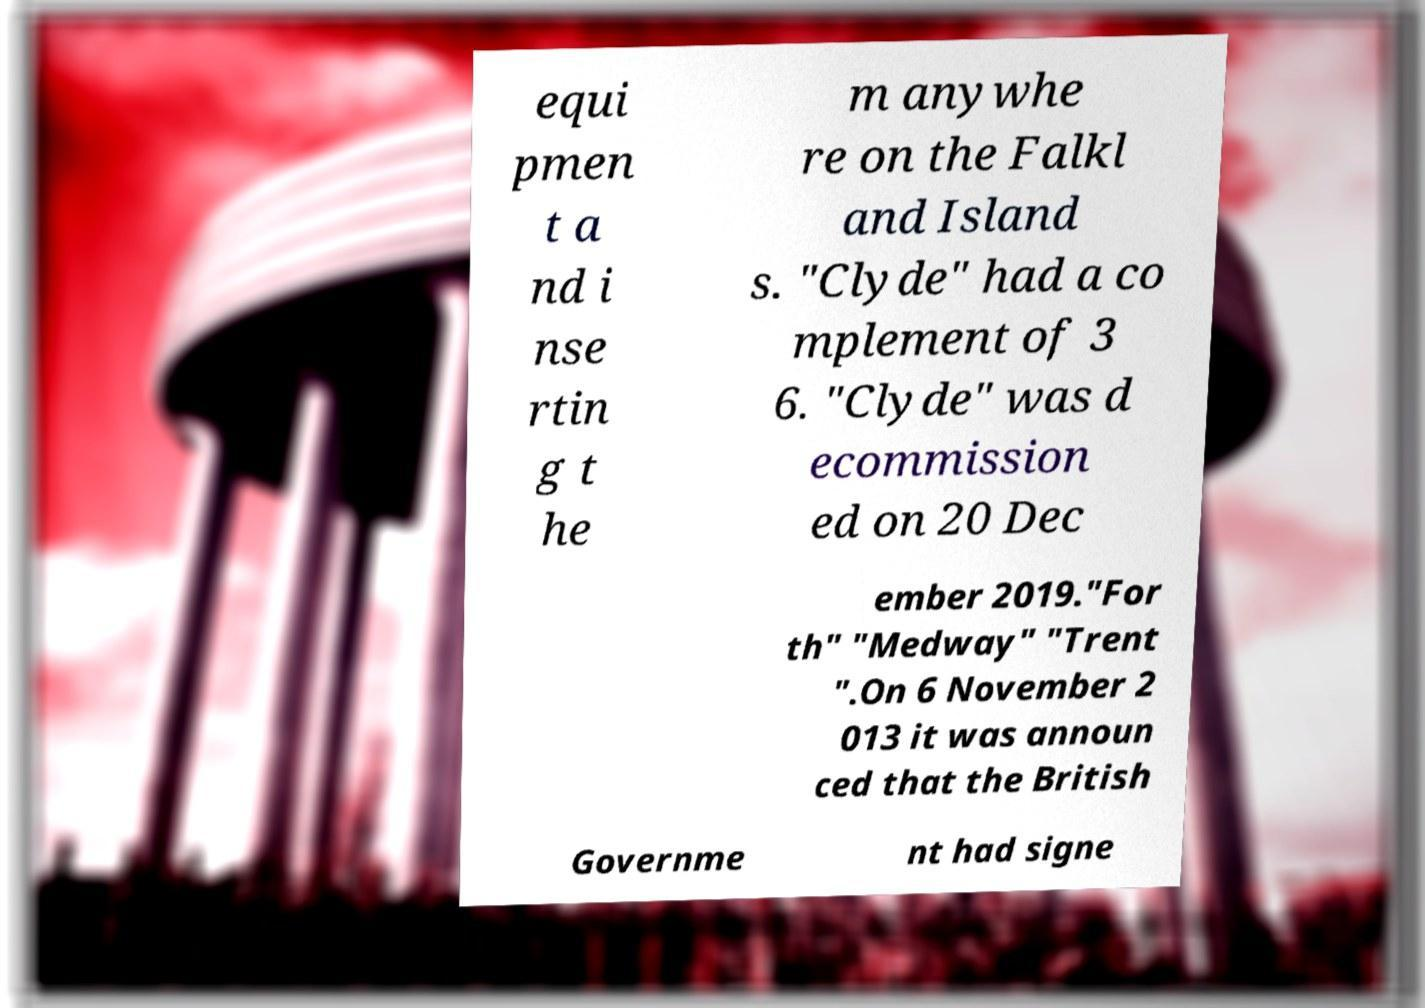Can you accurately transcribe the text from the provided image for me? equi pmen t a nd i nse rtin g t he m anywhe re on the Falkl and Island s. "Clyde" had a co mplement of 3 6. "Clyde" was d ecommission ed on 20 Dec ember 2019."For th" "Medway" "Trent ".On 6 November 2 013 it was announ ced that the British Governme nt had signe 